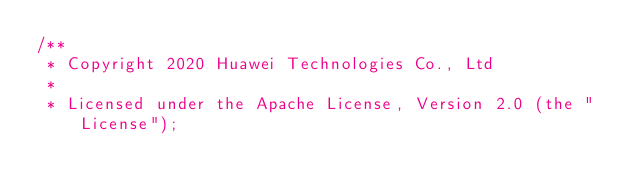Convert code to text. <code><loc_0><loc_0><loc_500><loc_500><_Cuda_>/**
 * Copyright 2020 Huawei Technologies Co., Ltd
 *
 * Licensed under the Apache License, Version 2.0 (the "License");</code> 